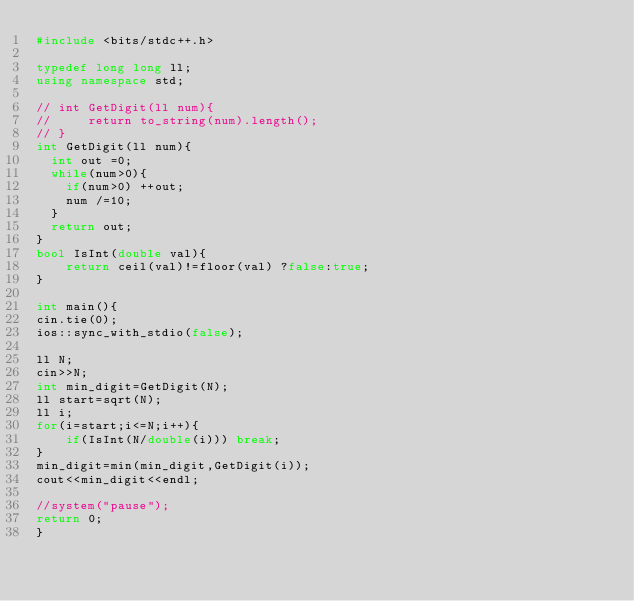<code> <loc_0><loc_0><loc_500><loc_500><_C++_>#include <bits/stdc++.h>

typedef long long ll;
using namespace std;

// int GetDigit(ll num){
//     return to_string(num).length();
// }
int GetDigit(ll num){
  int out =0;
  while(num>0){
    if(num>0) ++out;
    num /=10;
  }
  return out;
}
bool IsInt(double val){
    return ceil(val)!=floor(val) ?false:true;
}

int main(){
cin.tie(0);
ios::sync_with_stdio(false);

ll N;
cin>>N;
int min_digit=GetDigit(N);
ll start=sqrt(N);
ll i;
for(i=start;i<=N;i++){
    if(IsInt(N/double(i))) break;
}
min_digit=min(min_digit,GetDigit(i));
cout<<min_digit<<endl;

//system("pause");
return 0;
}</code> 